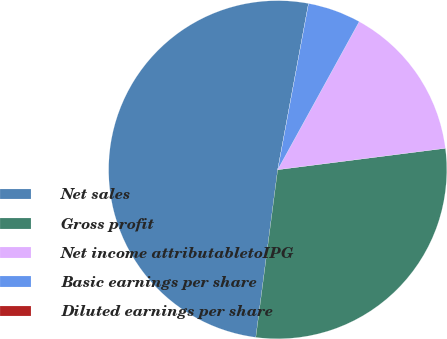Convert chart to OTSL. <chart><loc_0><loc_0><loc_500><loc_500><pie_chart><fcel>Net sales<fcel>Gross profit<fcel>Net income attributabletoIPG<fcel>Basic earnings per share<fcel>Diluted earnings per share<nl><fcel>50.85%<fcel>29.09%<fcel>14.97%<fcel>5.09%<fcel>0.0%<nl></chart> 